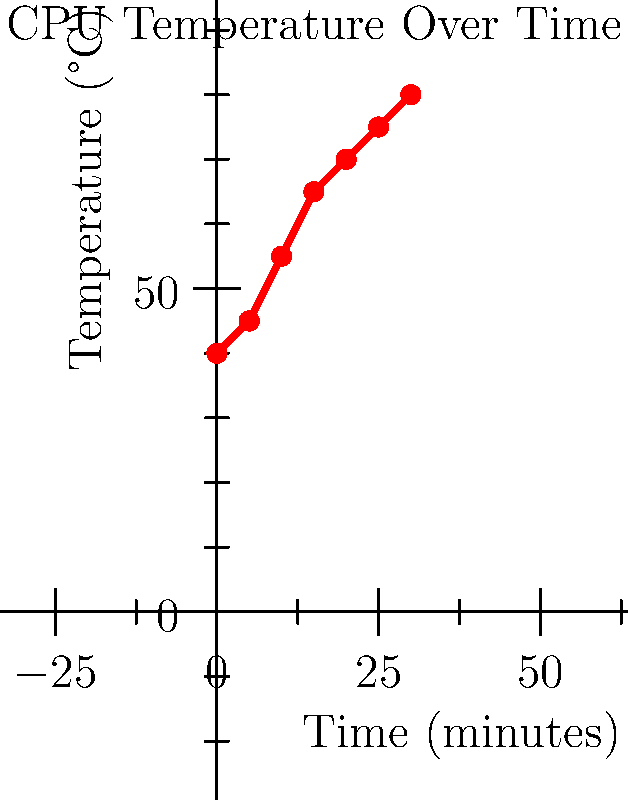As a computer technician, you're monitoring a CPU's temperature. Based on the graph, what is the approximate rate of temperature increase in degrees Celsius per minute during the first 15 minutes? To find the rate of temperature increase, we need to:

1. Identify the starting and ending points for the first 15 minutes:
   - At 0 minutes: 40°C
   - At 15 minutes: 65°C

2. Calculate the total temperature change:
   $\Delta T = 65°C - 40°C = 25°C$

3. Calculate the time interval:
   $\Delta t = 15 \text{ minutes} - 0 \text{ minutes} = 15 \text{ minutes}$

4. Use the formula for rate of change:
   $\text{Rate} = \frac{\Delta T}{\Delta t} = \frac{25°C}{15 \text{ minutes}} = \frac{5}{3}°C/\text{minute}$

5. Simplify the fraction:
   $\frac{5}{3}°C/\text{minute} \approx 1.67°C/\text{minute}$

Therefore, the approximate rate of temperature increase during the first 15 minutes is 1.67°C per minute.
Answer: 1.67°C/minute 